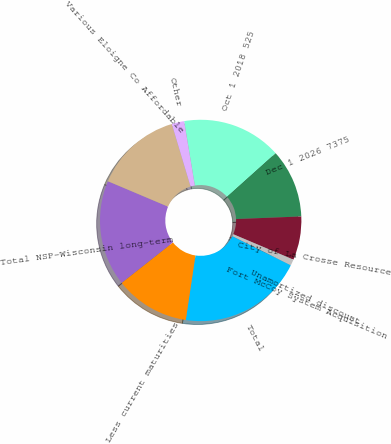Convert chart. <chart><loc_0><loc_0><loc_500><loc_500><pie_chart><fcel>Oct 1 2018 525<fcel>Dec 1 2026 7375<fcel>City of La Crosse Resource<fcel>Fort McCoy System Acquisition<fcel>Unamortized discount<fcel>Total<fcel>Less current maturities<fcel>Total NSP-Wisconsin long-term<fcel>Various Eloigne Co Affordable<fcel>Other<nl><fcel>16.0%<fcel>11.0%<fcel>7.0%<fcel>0.0%<fcel>1.0%<fcel>20.0%<fcel>12.0%<fcel>17.0%<fcel>14.0%<fcel>2.0%<nl></chart> 